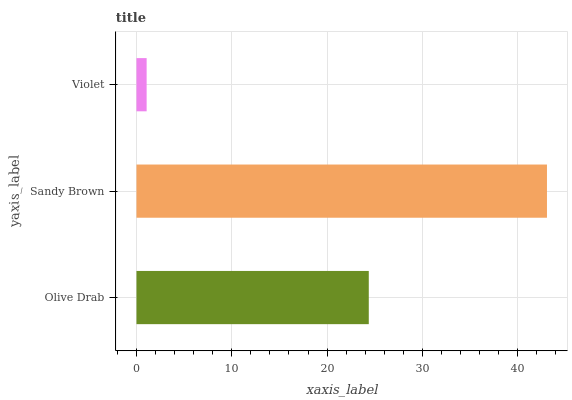Is Violet the minimum?
Answer yes or no. Yes. Is Sandy Brown the maximum?
Answer yes or no. Yes. Is Sandy Brown the minimum?
Answer yes or no. No. Is Violet the maximum?
Answer yes or no. No. Is Sandy Brown greater than Violet?
Answer yes or no. Yes. Is Violet less than Sandy Brown?
Answer yes or no. Yes. Is Violet greater than Sandy Brown?
Answer yes or no. No. Is Sandy Brown less than Violet?
Answer yes or no. No. Is Olive Drab the high median?
Answer yes or no. Yes. Is Olive Drab the low median?
Answer yes or no. Yes. Is Violet the high median?
Answer yes or no. No. Is Violet the low median?
Answer yes or no. No. 